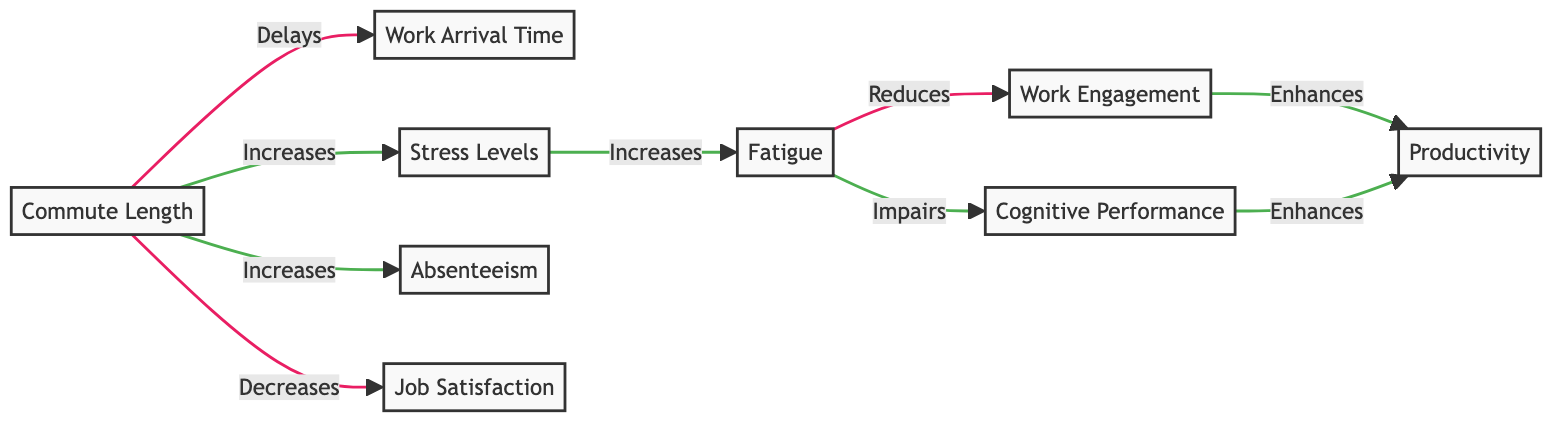What is the first node in the diagram? The first node listed in the diagram is "Commute Length." It originates the flow of relationships impacting workplace performance metrics.
Answer: Commute Length How many nodes are in the diagram? The diagram has a total of 9 nodes, as counted from the list of nodes provided. Each one represents a different metric related to workplace performance.
Answer: 9 What relationship does "Commute Length" have with "Work Arrival Time"? "Commute Length" has a negative relationship with "Work Arrival Time," indicating that longer commutes delay the time employees arrive at work.
Answer: negative Which node is negatively impacted by "Fatigue"? "Work Engagement" is negatively impacted by "Fatigue" as higher fatigue levels reduce an employee’s emotional and cognitive engagement with their work.
Answer: Work Engagement How does "Stress Levels" affect "Cognitive Performance"? "Stress Levels" positively affects "Cognitive Performance," meaning that increased stress can enhance cognitive function, although typically, this is paradoxical in practice.
Answer: positive What is the relationship between "Cognitive Performance" and "Productivity"? The relationship between "Cognitive Performance" and "Productivity" is positive, indicating that better cognitive performance enhances productivity levels.
Answer: positive How does increasing "Commute Length" affect "Job Satisfaction"? Increasing "Commute Length" has a negative effect on "Job Satisfaction," suggesting that longer commutes lead to lower levels of contentment with one’s job.
Answer: negative What is the connection between "Fatigue" and "Absenteeism"? "Fatigue" does not have a direct connection to "Absenteeism" in the provided diagram; rather, "Commute Length" is related positively to "Absenteeism."
Answer: no direct connection How many positive relationships are represented in the diagram? There are 5 positive relationships shown in the diagram connecting various nodes. This involves how several metrics enhance one another through the relationships mapped out.
Answer: 5 What node appears last in the flowchart? The last node in the diagram is "Productivity," which is influenced by several other metrics leading up to it, including "Cognitive Performance" and "Work Engagement."
Answer: Productivity 